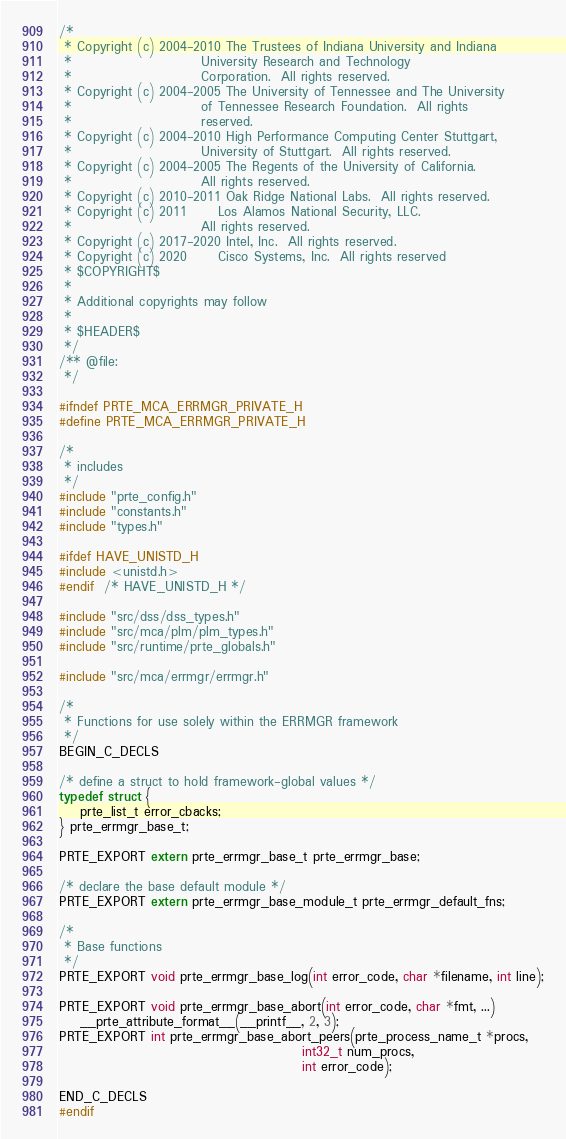Convert code to text. <code><loc_0><loc_0><loc_500><loc_500><_C_>/*
 * Copyright (c) 2004-2010 The Trustees of Indiana University and Indiana
 *                         University Research and Technology
 *                         Corporation.  All rights reserved.
 * Copyright (c) 2004-2005 The University of Tennessee and The University
 *                         of Tennessee Research Foundation.  All rights
 *                         reserved.
 * Copyright (c) 2004-2010 High Performance Computing Center Stuttgart,
 *                         University of Stuttgart.  All rights reserved.
 * Copyright (c) 2004-2005 The Regents of the University of California.
 *                         All rights reserved.
 * Copyright (c) 2010-2011 Oak Ridge National Labs.  All rights reserved.
 * Copyright (c) 2011      Los Alamos National Security, LLC.
 *                         All rights reserved.
 * Copyright (c) 2017-2020 Intel, Inc.  All rights reserved.
 * Copyright (c) 2020      Cisco Systems, Inc.  All rights reserved
 * $COPYRIGHT$
 *
 * Additional copyrights may follow
 *
 * $HEADER$
 */
/** @file:
 */

#ifndef PRTE_MCA_ERRMGR_PRIVATE_H
#define PRTE_MCA_ERRMGR_PRIVATE_H

/*
 * includes
 */
#include "prte_config.h"
#include "constants.h"
#include "types.h"

#ifdef HAVE_UNISTD_H
#include <unistd.h>
#endif  /* HAVE_UNISTD_H */

#include "src/dss/dss_types.h"
#include "src/mca/plm/plm_types.h"
#include "src/runtime/prte_globals.h"

#include "src/mca/errmgr/errmgr.h"

/*
 * Functions for use solely within the ERRMGR framework
 */
BEGIN_C_DECLS

/* define a struct to hold framework-global values */
typedef struct {
    prte_list_t error_cbacks;
} prte_errmgr_base_t;

PRTE_EXPORT extern prte_errmgr_base_t prte_errmgr_base;

/* declare the base default module */
PRTE_EXPORT extern prte_errmgr_base_module_t prte_errmgr_default_fns;

/*
 * Base functions
 */
PRTE_EXPORT void prte_errmgr_base_log(int error_code, char *filename, int line);

PRTE_EXPORT void prte_errmgr_base_abort(int error_code, char *fmt, ...)
    __prte_attribute_format__(__printf__, 2, 3);
PRTE_EXPORT int prte_errmgr_base_abort_peers(prte_process_name_t *procs,
                                               int32_t num_procs,
                                               int error_code);

END_C_DECLS
#endif
</code> 